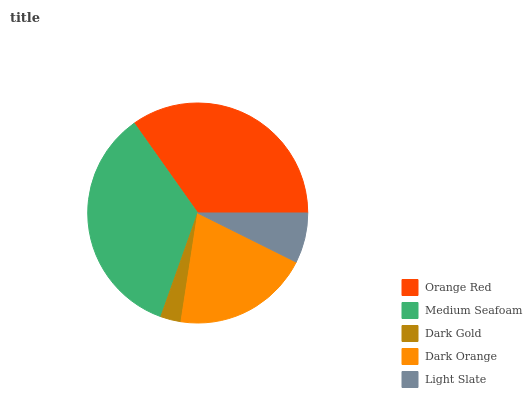Is Dark Gold the minimum?
Answer yes or no. Yes. Is Orange Red the maximum?
Answer yes or no. Yes. Is Medium Seafoam the minimum?
Answer yes or no. No. Is Medium Seafoam the maximum?
Answer yes or no. No. Is Orange Red greater than Medium Seafoam?
Answer yes or no. Yes. Is Medium Seafoam less than Orange Red?
Answer yes or no. Yes. Is Medium Seafoam greater than Orange Red?
Answer yes or no. No. Is Orange Red less than Medium Seafoam?
Answer yes or no. No. Is Dark Orange the high median?
Answer yes or no. Yes. Is Dark Orange the low median?
Answer yes or no. Yes. Is Medium Seafoam the high median?
Answer yes or no. No. Is Dark Gold the low median?
Answer yes or no. No. 